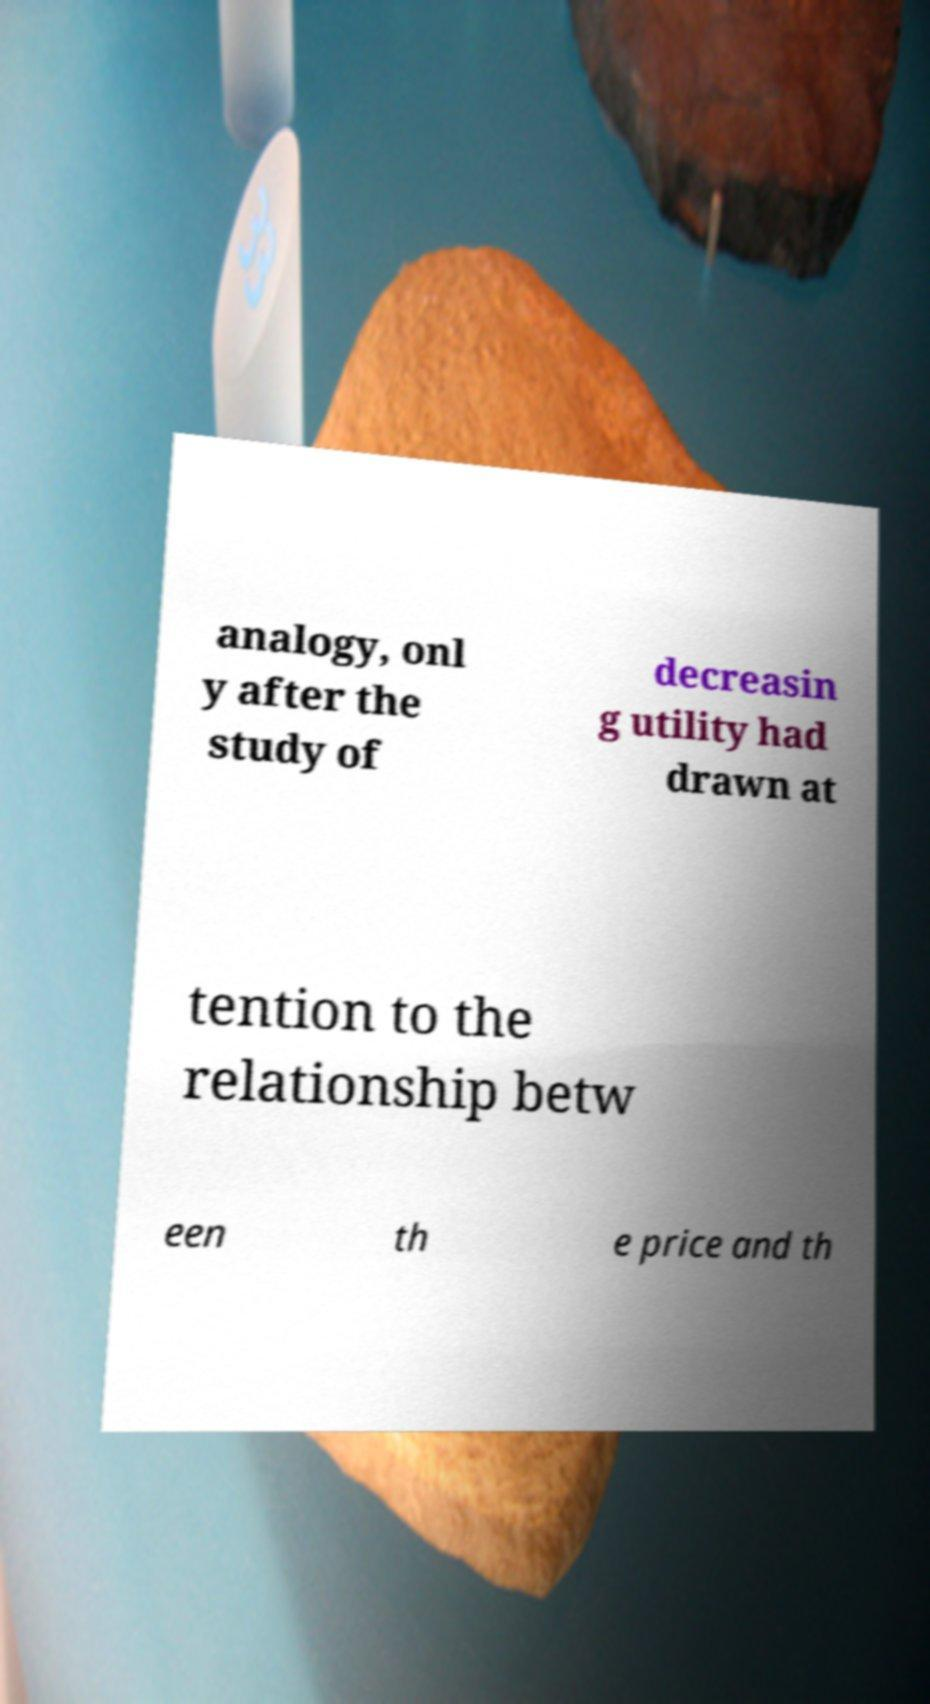Can you read and provide the text displayed in the image?This photo seems to have some interesting text. Can you extract and type it out for me? analogy, onl y after the study of decreasin g utility had drawn at tention to the relationship betw een th e price and th 